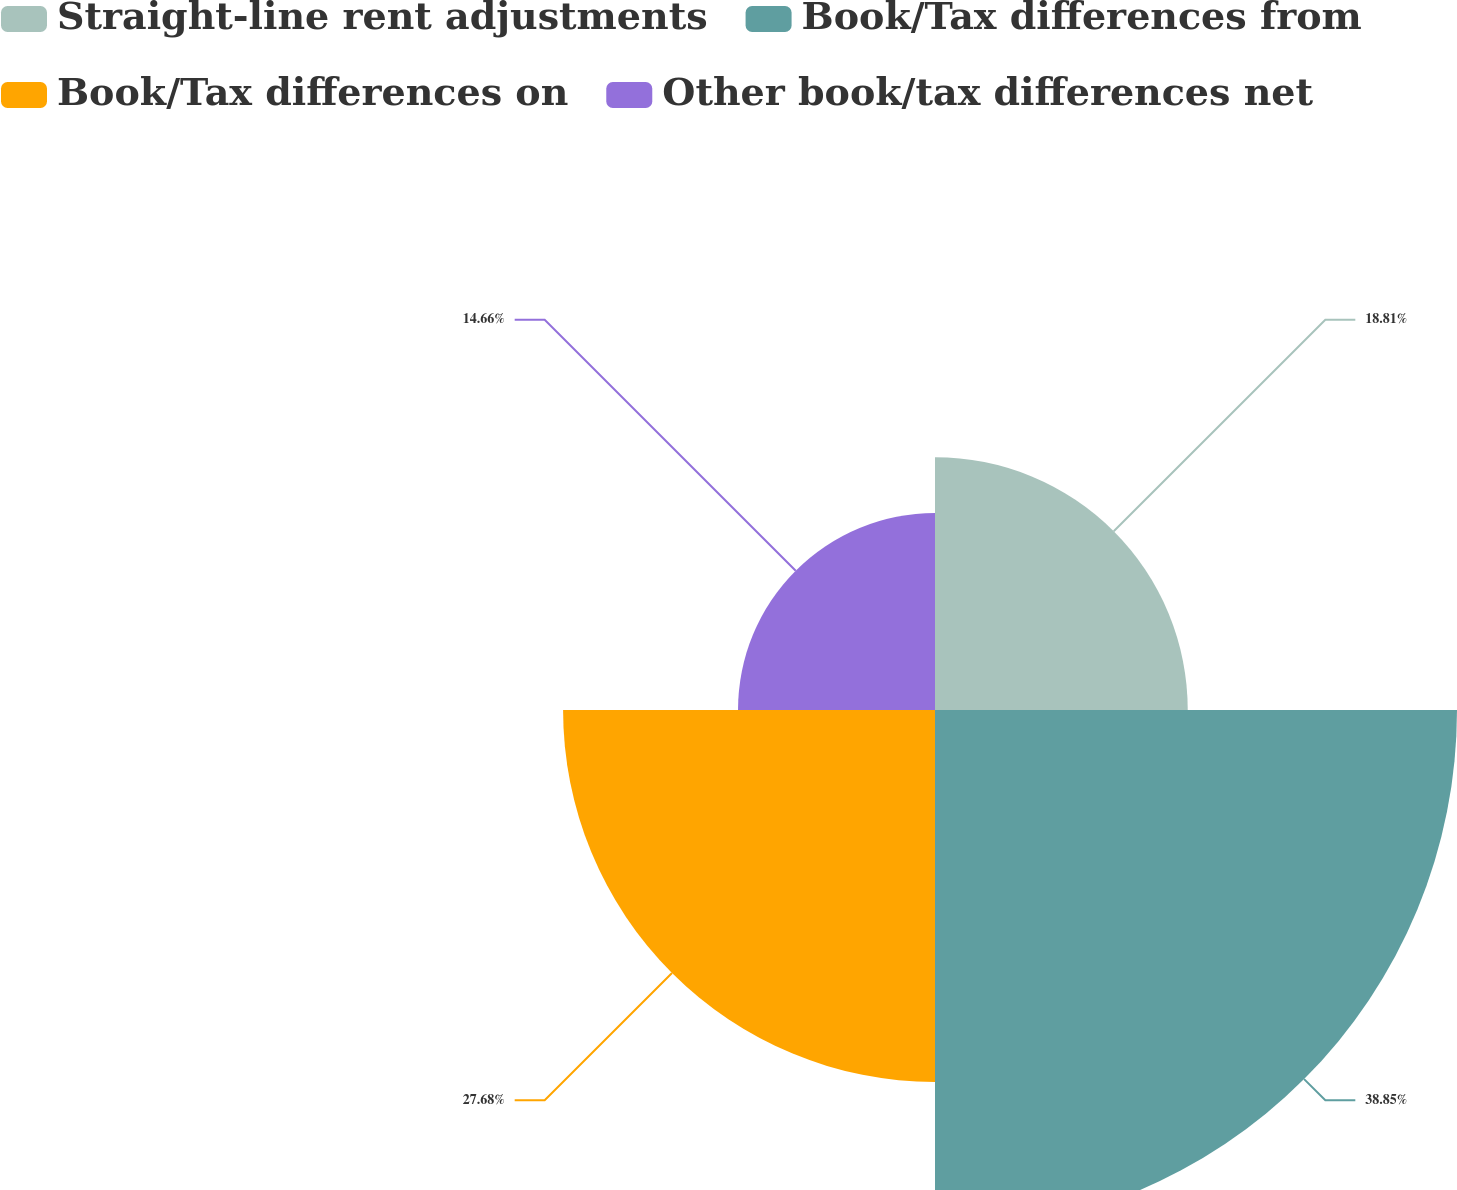<chart> <loc_0><loc_0><loc_500><loc_500><pie_chart><fcel>Straight-line rent adjustments<fcel>Book/Tax differences from<fcel>Book/Tax differences on<fcel>Other book/tax differences net<nl><fcel>18.81%<fcel>38.85%<fcel>27.68%<fcel>14.66%<nl></chart> 